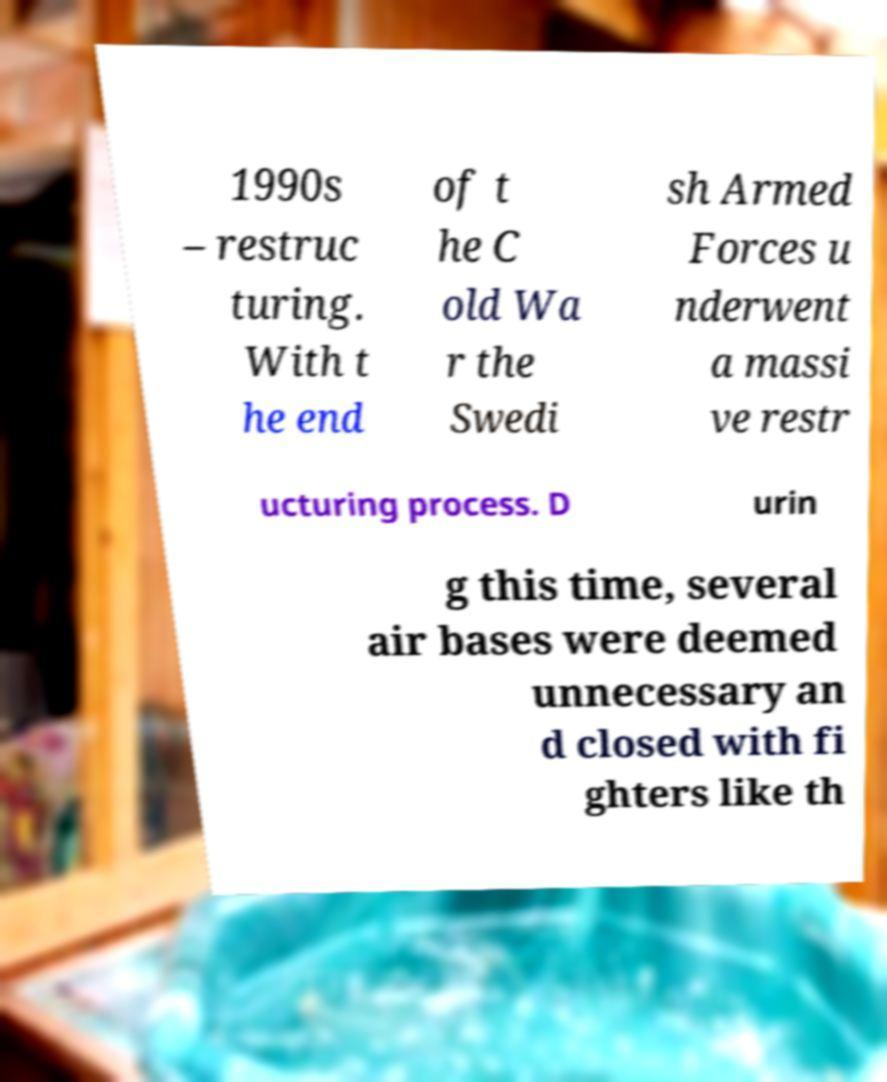There's text embedded in this image that I need extracted. Can you transcribe it verbatim? 1990s – restruc turing. With t he end of t he C old Wa r the Swedi sh Armed Forces u nderwent a massi ve restr ucturing process. D urin g this time, several air bases were deemed unnecessary an d closed with fi ghters like th 